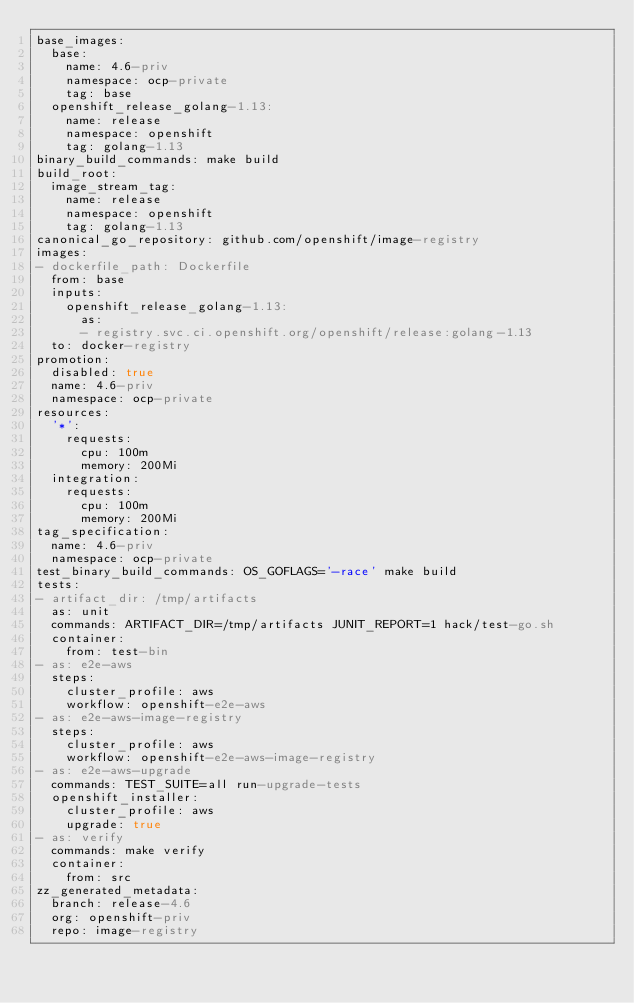Convert code to text. <code><loc_0><loc_0><loc_500><loc_500><_YAML_>base_images:
  base:
    name: 4.6-priv
    namespace: ocp-private
    tag: base
  openshift_release_golang-1.13:
    name: release
    namespace: openshift
    tag: golang-1.13
binary_build_commands: make build
build_root:
  image_stream_tag:
    name: release
    namespace: openshift
    tag: golang-1.13
canonical_go_repository: github.com/openshift/image-registry
images:
- dockerfile_path: Dockerfile
  from: base
  inputs:
    openshift_release_golang-1.13:
      as:
      - registry.svc.ci.openshift.org/openshift/release:golang-1.13
  to: docker-registry
promotion:
  disabled: true
  name: 4.6-priv
  namespace: ocp-private
resources:
  '*':
    requests:
      cpu: 100m
      memory: 200Mi
  integration:
    requests:
      cpu: 100m
      memory: 200Mi
tag_specification:
  name: 4.6-priv
  namespace: ocp-private
test_binary_build_commands: OS_GOFLAGS='-race' make build
tests:
- artifact_dir: /tmp/artifacts
  as: unit
  commands: ARTIFACT_DIR=/tmp/artifacts JUNIT_REPORT=1 hack/test-go.sh
  container:
    from: test-bin
- as: e2e-aws
  steps:
    cluster_profile: aws
    workflow: openshift-e2e-aws
- as: e2e-aws-image-registry
  steps:
    cluster_profile: aws
    workflow: openshift-e2e-aws-image-registry
- as: e2e-aws-upgrade
  commands: TEST_SUITE=all run-upgrade-tests
  openshift_installer:
    cluster_profile: aws
    upgrade: true
- as: verify
  commands: make verify
  container:
    from: src
zz_generated_metadata:
  branch: release-4.6
  org: openshift-priv
  repo: image-registry
</code> 